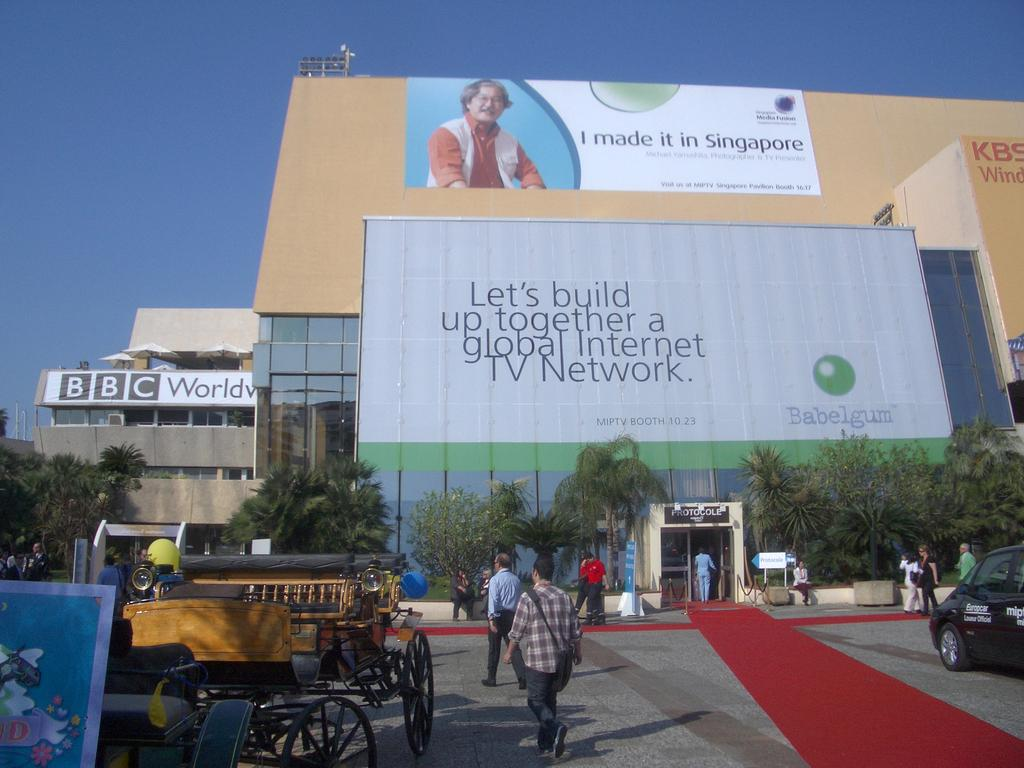Provide a one-sentence caption for the provided image. Billboard that says "Let's build up together" outdoors on a sunny day. 